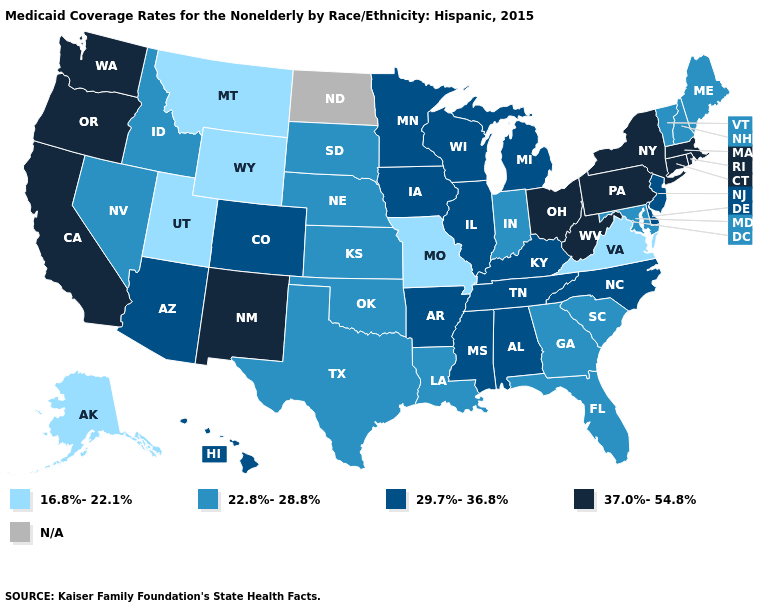What is the value of Maine?
Be succinct. 22.8%-28.8%. Among the states that border Utah , does Idaho have the highest value?
Write a very short answer. No. Among the states that border Alabama , which have the highest value?
Keep it brief. Mississippi, Tennessee. What is the value of Louisiana?
Answer briefly. 22.8%-28.8%. Which states have the lowest value in the West?
Concise answer only. Alaska, Montana, Utah, Wyoming. Which states hav the highest value in the West?
Short answer required. California, New Mexico, Oregon, Washington. Which states have the highest value in the USA?
Concise answer only. California, Connecticut, Massachusetts, New Mexico, New York, Ohio, Oregon, Pennsylvania, Rhode Island, Washington, West Virginia. Among the states that border South Carolina , which have the lowest value?
Answer briefly. Georgia. Name the states that have a value in the range 16.8%-22.1%?
Answer briefly. Alaska, Missouri, Montana, Utah, Virginia, Wyoming. What is the lowest value in the Northeast?
Short answer required. 22.8%-28.8%. Which states have the highest value in the USA?
Give a very brief answer. California, Connecticut, Massachusetts, New Mexico, New York, Ohio, Oregon, Pennsylvania, Rhode Island, Washington, West Virginia. Is the legend a continuous bar?
Write a very short answer. No. What is the value of North Carolina?
Be succinct. 29.7%-36.8%. What is the lowest value in states that border Minnesota?
Write a very short answer. 22.8%-28.8%. 